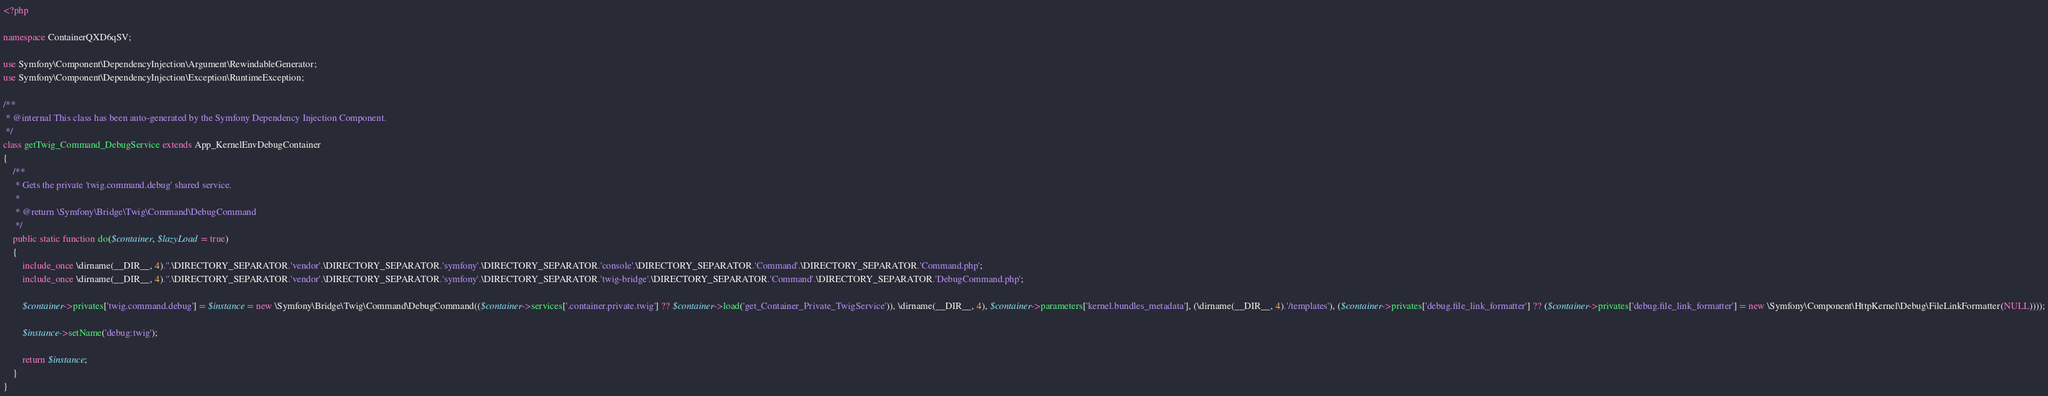<code> <loc_0><loc_0><loc_500><loc_500><_PHP_><?php

namespace ContainerQXD6qSV;

use Symfony\Component\DependencyInjection\Argument\RewindableGenerator;
use Symfony\Component\DependencyInjection\Exception\RuntimeException;

/**
 * @internal This class has been auto-generated by the Symfony Dependency Injection Component.
 */
class getTwig_Command_DebugService extends App_KernelEnvDebugContainer
{
    /**
     * Gets the private 'twig.command.debug' shared service.
     *
     * @return \Symfony\Bridge\Twig\Command\DebugCommand
     */
    public static function do($container, $lazyLoad = true)
    {
        include_once \dirname(__DIR__, 4).''.\DIRECTORY_SEPARATOR.'vendor'.\DIRECTORY_SEPARATOR.'symfony'.\DIRECTORY_SEPARATOR.'console'.\DIRECTORY_SEPARATOR.'Command'.\DIRECTORY_SEPARATOR.'Command.php';
        include_once \dirname(__DIR__, 4).''.\DIRECTORY_SEPARATOR.'vendor'.\DIRECTORY_SEPARATOR.'symfony'.\DIRECTORY_SEPARATOR.'twig-bridge'.\DIRECTORY_SEPARATOR.'Command'.\DIRECTORY_SEPARATOR.'DebugCommand.php';

        $container->privates['twig.command.debug'] = $instance = new \Symfony\Bridge\Twig\Command\DebugCommand(($container->services['.container.private.twig'] ?? $container->load('get_Container_Private_TwigService')), \dirname(__DIR__, 4), $container->parameters['kernel.bundles_metadata'], (\dirname(__DIR__, 4).'/templates'), ($container->privates['debug.file_link_formatter'] ?? ($container->privates['debug.file_link_formatter'] = new \Symfony\Component\HttpKernel\Debug\FileLinkFormatter(NULL))));

        $instance->setName('debug:twig');

        return $instance;
    }
}
</code> 